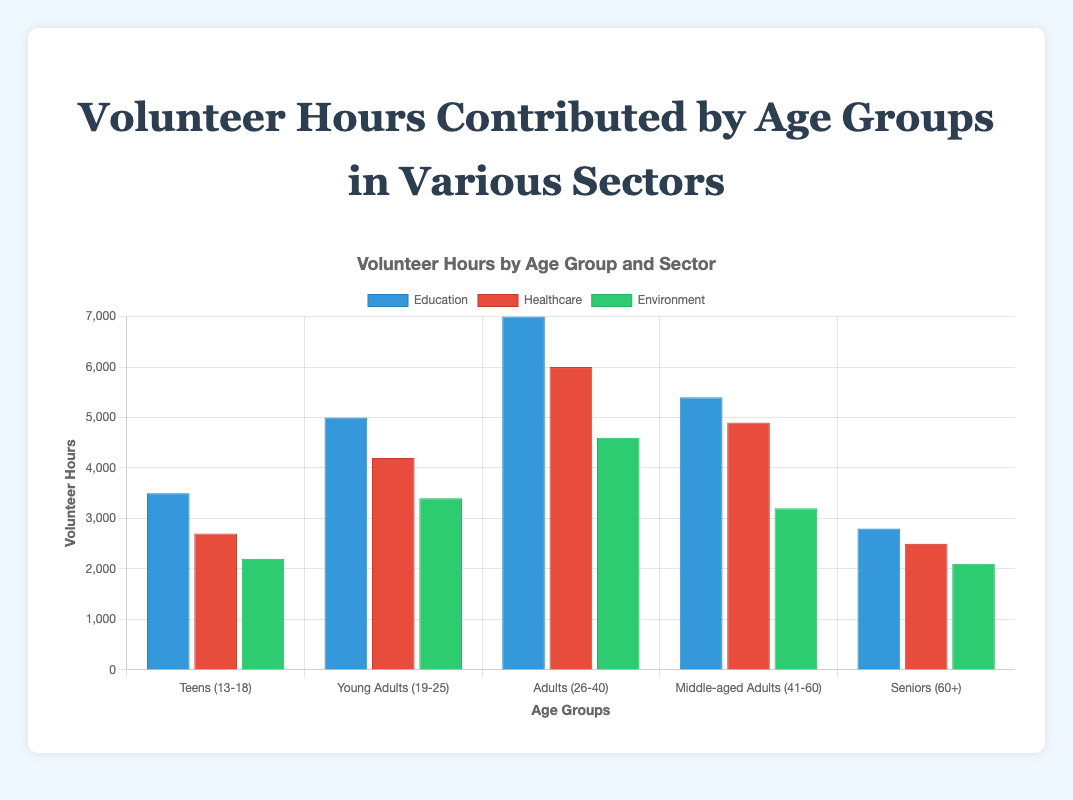Which age group contributed the most volunteer hours in the Education sector? By observing the heights of the different colored bars representing the Education sector across all age groups, we see that the bar for Adults (26-40) is the longest.
Answer: Adults (26-40) For the Healthcare sector, what is the difference in volunteer hours between Young Adults (19-25) and Seniors (60+)? The bar representing Healthcare for Young Adults (19-25) indicates 4200 hours, while the bar for Seniors (60+) indicates 2500 hours. The difference is 4200 - 2500.
Answer: 1700 Which sector saw the least volunteer hours contributed by Teens (13-18)? By observing the heights of the bars for Teens (13-18) across all sectors, we notice the shortest bar is for the Environment sector.
Answer: Environment What is the total volunteer hours contributed by Middle-aged Adults (41-60) across all sectors? Sum the hours Middle-aged Adults (41-60) contributed in each sector: 5400 (Education) + 4900 (Healthcare) + 3200 (Environment) = 13500 hours.
Answer: 13500 Compare the volunteer hours between Environment sector for Adults (26-40) and Healthcare sector for Teens (13-18). Which is higher? The bar for Adults (26-40) in the Environment sector is 4600, while the bar for Teens (13-18) in the Healthcare sector is 2700. 4600 > 2700.
Answer: Environment for Adults (26-40) What is the average volunteer hours contributed by Young Adults (19-25) in all sectors? The hours for Young Adults (19-25) are 5000 (Education) + 4200 (Healthcare) + 3400 (Environment). Sum these and divide by 3: (5000 + 4200 + 3400) / 3 = 12600 / 3 = 4200.
Answer: 4200 Which sector has the largest variation in volunteer hours among all age groups? Education sector's bars show the largest range in height, from Teens (3500) to Adults (7000), creating the greatest variation.
Answer: Education How many more hours did Teens (13-18) contribute to Education than to Environment? The bar for Teens in Education shows 3500 hours, and in Environment it shows 2200 hours. The difference is 3500 - 2200.
Answer: 1300 Which sector's bars have the most consistent heights across all age groups? By observing the bar heights for each sector, the Healthcare sector's bars are closest in height across all age groups.
Answer: Healthcare 